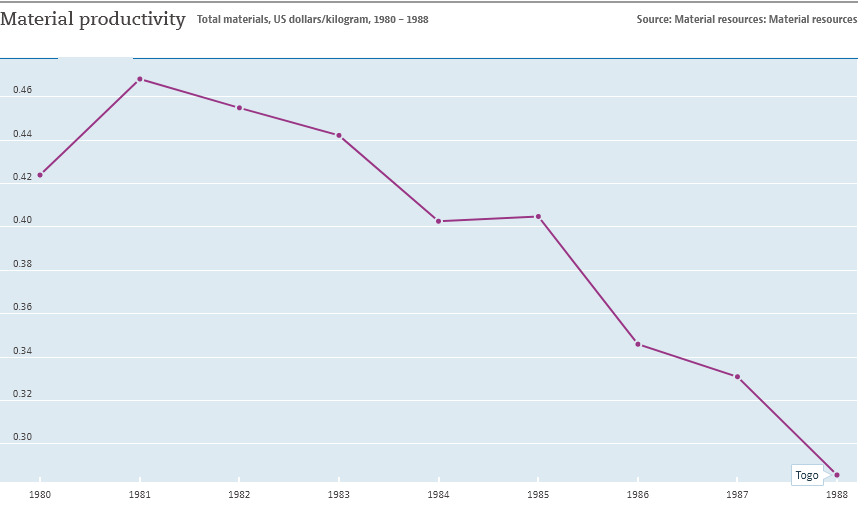Highlight a few significant elements in this photo. The value of material productivity in the 1980s was greater than in 1988. The graph shows a significant increase in material productivity over a period of nine years. 